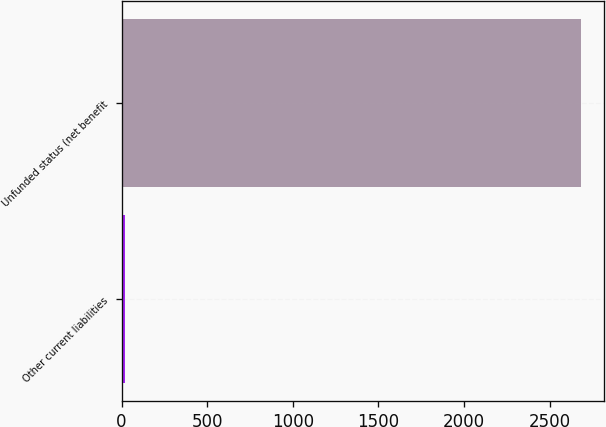<chart> <loc_0><loc_0><loc_500><loc_500><bar_chart><fcel>Other current liabilities<fcel>Unfunded status (net benefit<nl><fcel>23<fcel>2685<nl></chart> 